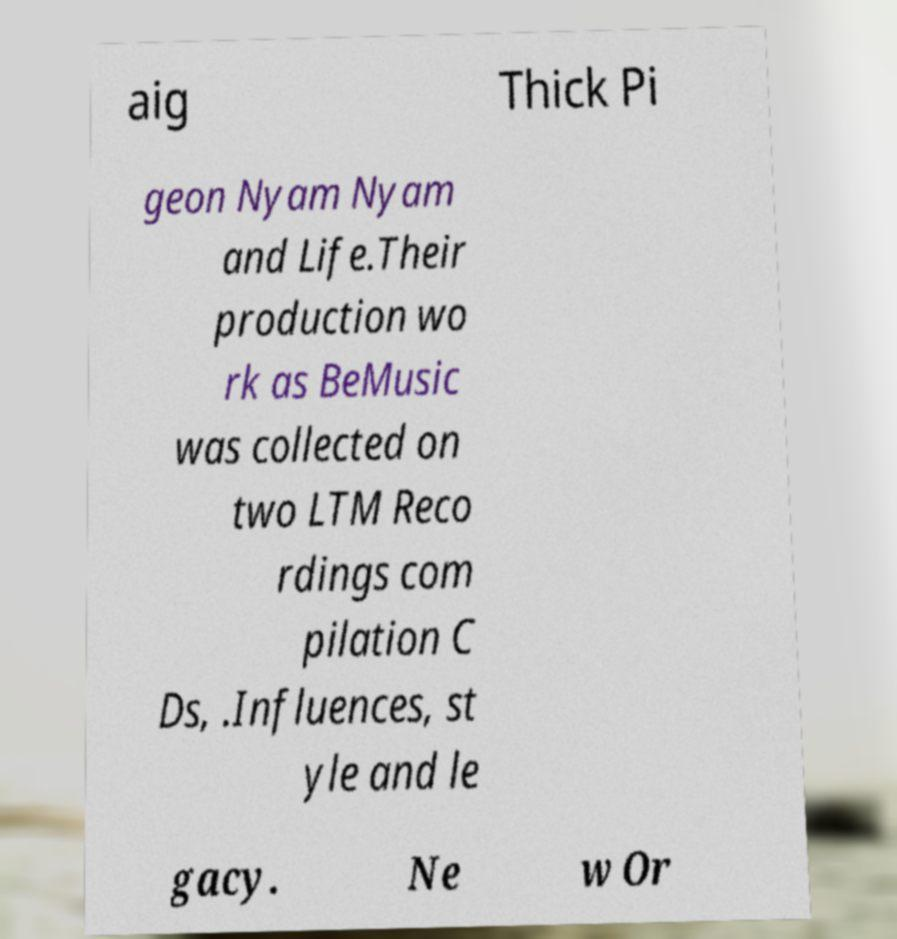What messages or text are displayed in this image? I need them in a readable, typed format. aig Thick Pi geon Nyam Nyam and Life.Their production wo rk as BeMusic was collected on two LTM Reco rdings com pilation C Ds, .Influences, st yle and le gacy. Ne w Or 